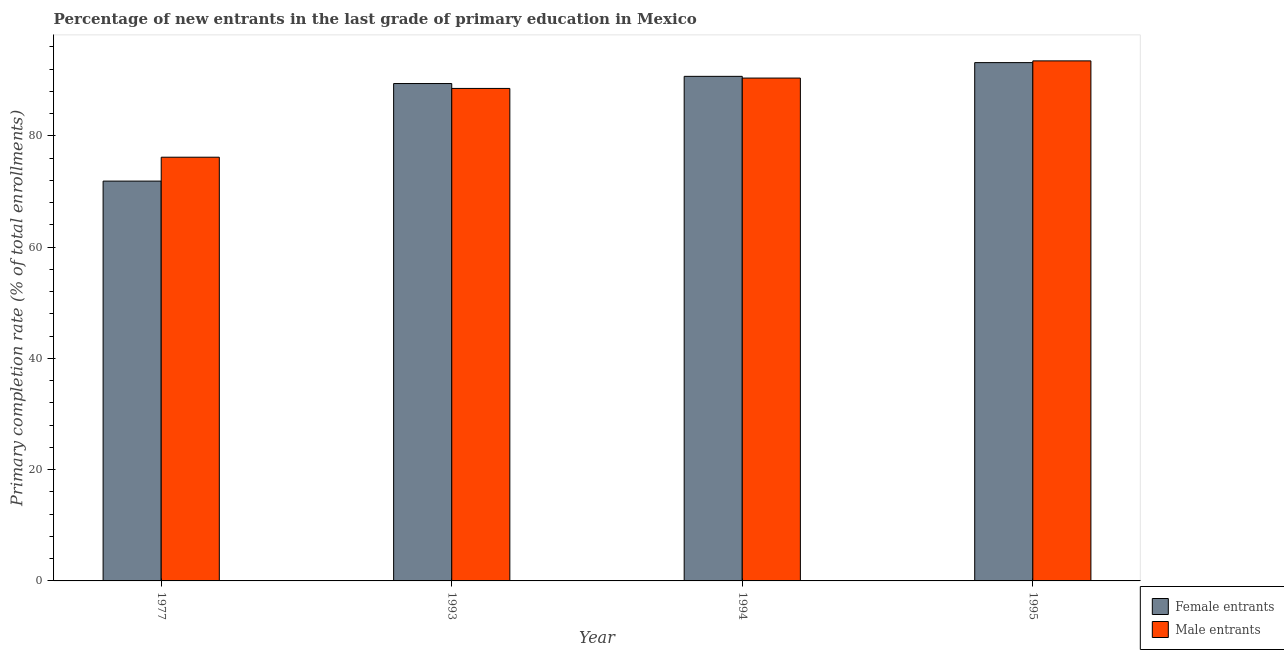How many different coloured bars are there?
Your response must be concise. 2. How many groups of bars are there?
Your answer should be compact. 4. Are the number of bars per tick equal to the number of legend labels?
Provide a short and direct response. Yes. How many bars are there on the 1st tick from the right?
Your answer should be very brief. 2. What is the label of the 1st group of bars from the left?
Ensure brevity in your answer.  1977. In how many cases, is the number of bars for a given year not equal to the number of legend labels?
Make the answer very short. 0. What is the primary completion rate of male entrants in 1995?
Offer a very short reply. 93.47. Across all years, what is the maximum primary completion rate of male entrants?
Give a very brief answer. 93.47. Across all years, what is the minimum primary completion rate of male entrants?
Ensure brevity in your answer.  76.16. What is the total primary completion rate of male entrants in the graph?
Make the answer very short. 348.52. What is the difference between the primary completion rate of male entrants in 1977 and that in 1993?
Offer a terse response. -12.36. What is the difference between the primary completion rate of male entrants in 1994 and the primary completion rate of female entrants in 1977?
Provide a short and direct response. 14.22. What is the average primary completion rate of female entrants per year?
Your answer should be compact. 86.28. In the year 1993, what is the difference between the primary completion rate of female entrants and primary completion rate of male entrants?
Your response must be concise. 0. What is the ratio of the primary completion rate of female entrants in 1977 to that in 1994?
Provide a short and direct response. 0.79. Is the primary completion rate of male entrants in 1993 less than that in 1995?
Provide a succinct answer. Yes. What is the difference between the highest and the second highest primary completion rate of male entrants?
Your answer should be very brief. 3.09. What is the difference between the highest and the lowest primary completion rate of male entrants?
Offer a terse response. 17.31. What does the 2nd bar from the left in 1993 represents?
Your answer should be compact. Male entrants. What does the 1st bar from the right in 1995 represents?
Keep it short and to the point. Male entrants. Are all the bars in the graph horizontal?
Your response must be concise. No. How many legend labels are there?
Make the answer very short. 2. How are the legend labels stacked?
Your answer should be compact. Vertical. What is the title of the graph?
Make the answer very short. Percentage of new entrants in the last grade of primary education in Mexico. Does "Export" appear as one of the legend labels in the graph?
Give a very brief answer. No. What is the label or title of the Y-axis?
Ensure brevity in your answer.  Primary completion rate (% of total enrollments). What is the Primary completion rate (% of total enrollments) in Female entrants in 1977?
Your answer should be compact. 71.86. What is the Primary completion rate (% of total enrollments) of Male entrants in 1977?
Keep it short and to the point. 76.16. What is the Primary completion rate (% of total enrollments) of Female entrants in 1993?
Your answer should be compact. 89.4. What is the Primary completion rate (% of total enrollments) in Male entrants in 1993?
Your answer should be very brief. 88.52. What is the Primary completion rate (% of total enrollments) of Female entrants in 1994?
Provide a succinct answer. 90.69. What is the Primary completion rate (% of total enrollments) in Male entrants in 1994?
Keep it short and to the point. 90.38. What is the Primary completion rate (% of total enrollments) of Female entrants in 1995?
Keep it short and to the point. 93.16. What is the Primary completion rate (% of total enrollments) of Male entrants in 1995?
Offer a very short reply. 93.47. Across all years, what is the maximum Primary completion rate (% of total enrollments) of Female entrants?
Offer a very short reply. 93.16. Across all years, what is the maximum Primary completion rate (% of total enrollments) of Male entrants?
Provide a short and direct response. 93.47. Across all years, what is the minimum Primary completion rate (% of total enrollments) in Female entrants?
Your answer should be compact. 71.86. Across all years, what is the minimum Primary completion rate (% of total enrollments) of Male entrants?
Give a very brief answer. 76.16. What is the total Primary completion rate (% of total enrollments) of Female entrants in the graph?
Ensure brevity in your answer.  345.11. What is the total Primary completion rate (% of total enrollments) of Male entrants in the graph?
Your answer should be very brief. 348.52. What is the difference between the Primary completion rate (% of total enrollments) of Female entrants in 1977 and that in 1993?
Provide a succinct answer. -17.54. What is the difference between the Primary completion rate (% of total enrollments) in Male entrants in 1977 and that in 1993?
Your answer should be very brief. -12.36. What is the difference between the Primary completion rate (% of total enrollments) in Female entrants in 1977 and that in 1994?
Your answer should be very brief. -18.83. What is the difference between the Primary completion rate (% of total enrollments) of Male entrants in 1977 and that in 1994?
Give a very brief answer. -14.22. What is the difference between the Primary completion rate (% of total enrollments) of Female entrants in 1977 and that in 1995?
Your response must be concise. -21.29. What is the difference between the Primary completion rate (% of total enrollments) of Male entrants in 1977 and that in 1995?
Provide a short and direct response. -17.31. What is the difference between the Primary completion rate (% of total enrollments) in Female entrants in 1993 and that in 1994?
Offer a terse response. -1.29. What is the difference between the Primary completion rate (% of total enrollments) in Male entrants in 1993 and that in 1994?
Offer a terse response. -1.86. What is the difference between the Primary completion rate (% of total enrollments) in Female entrants in 1993 and that in 1995?
Make the answer very short. -3.76. What is the difference between the Primary completion rate (% of total enrollments) of Male entrants in 1993 and that in 1995?
Make the answer very short. -4.95. What is the difference between the Primary completion rate (% of total enrollments) of Female entrants in 1994 and that in 1995?
Keep it short and to the point. -2.47. What is the difference between the Primary completion rate (% of total enrollments) in Male entrants in 1994 and that in 1995?
Offer a very short reply. -3.09. What is the difference between the Primary completion rate (% of total enrollments) of Female entrants in 1977 and the Primary completion rate (% of total enrollments) of Male entrants in 1993?
Your answer should be compact. -16.66. What is the difference between the Primary completion rate (% of total enrollments) of Female entrants in 1977 and the Primary completion rate (% of total enrollments) of Male entrants in 1994?
Provide a succinct answer. -18.52. What is the difference between the Primary completion rate (% of total enrollments) in Female entrants in 1977 and the Primary completion rate (% of total enrollments) in Male entrants in 1995?
Your answer should be compact. -21.61. What is the difference between the Primary completion rate (% of total enrollments) in Female entrants in 1993 and the Primary completion rate (% of total enrollments) in Male entrants in 1994?
Make the answer very short. -0.98. What is the difference between the Primary completion rate (% of total enrollments) in Female entrants in 1993 and the Primary completion rate (% of total enrollments) in Male entrants in 1995?
Your response must be concise. -4.07. What is the difference between the Primary completion rate (% of total enrollments) in Female entrants in 1994 and the Primary completion rate (% of total enrollments) in Male entrants in 1995?
Your response must be concise. -2.78. What is the average Primary completion rate (% of total enrollments) of Female entrants per year?
Give a very brief answer. 86.28. What is the average Primary completion rate (% of total enrollments) of Male entrants per year?
Provide a short and direct response. 87.13. In the year 1977, what is the difference between the Primary completion rate (% of total enrollments) of Female entrants and Primary completion rate (% of total enrollments) of Male entrants?
Offer a terse response. -4.29. In the year 1993, what is the difference between the Primary completion rate (% of total enrollments) of Female entrants and Primary completion rate (% of total enrollments) of Male entrants?
Your response must be concise. 0.88. In the year 1994, what is the difference between the Primary completion rate (% of total enrollments) of Female entrants and Primary completion rate (% of total enrollments) of Male entrants?
Keep it short and to the point. 0.31. In the year 1995, what is the difference between the Primary completion rate (% of total enrollments) in Female entrants and Primary completion rate (% of total enrollments) in Male entrants?
Keep it short and to the point. -0.31. What is the ratio of the Primary completion rate (% of total enrollments) in Female entrants in 1977 to that in 1993?
Offer a terse response. 0.8. What is the ratio of the Primary completion rate (% of total enrollments) in Male entrants in 1977 to that in 1993?
Your answer should be compact. 0.86. What is the ratio of the Primary completion rate (% of total enrollments) of Female entrants in 1977 to that in 1994?
Give a very brief answer. 0.79. What is the ratio of the Primary completion rate (% of total enrollments) of Male entrants in 1977 to that in 1994?
Keep it short and to the point. 0.84. What is the ratio of the Primary completion rate (% of total enrollments) in Female entrants in 1977 to that in 1995?
Make the answer very short. 0.77. What is the ratio of the Primary completion rate (% of total enrollments) of Male entrants in 1977 to that in 1995?
Provide a succinct answer. 0.81. What is the ratio of the Primary completion rate (% of total enrollments) of Female entrants in 1993 to that in 1994?
Make the answer very short. 0.99. What is the ratio of the Primary completion rate (% of total enrollments) in Male entrants in 1993 to that in 1994?
Provide a succinct answer. 0.98. What is the ratio of the Primary completion rate (% of total enrollments) in Female entrants in 1993 to that in 1995?
Your answer should be very brief. 0.96. What is the ratio of the Primary completion rate (% of total enrollments) in Male entrants in 1993 to that in 1995?
Your answer should be compact. 0.95. What is the ratio of the Primary completion rate (% of total enrollments) in Female entrants in 1994 to that in 1995?
Make the answer very short. 0.97. What is the ratio of the Primary completion rate (% of total enrollments) in Male entrants in 1994 to that in 1995?
Ensure brevity in your answer.  0.97. What is the difference between the highest and the second highest Primary completion rate (% of total enrollments) of Female entrants?
Provide a succinct answer. 2.47. What is the difference between the highest and the second highest Primary completion rate (% of total enrollments) of Male entrants?
Provide a succinct answer. 3.09. What is the difference between the highest and the lowest Primary completion rate (% of total enrollments) of Female entrants?
Your answer should be very brief. 21.29. What is the difference between the highest and the lowest Primary completion rate (% of total enrollments) of Male entrants?
Make the answer very short. 17.31. 